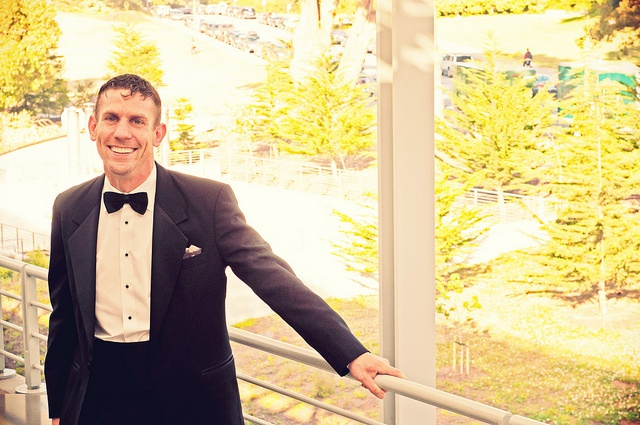Describe the objects in this image and their specific colors. I can see people in gold, black, tan, purple, and brown tones, car in gold, ivory, khaki, and tan tones, tie in gold, black, gray, tan, and darkgray tones, car in gold, khaki, beige, and darkgray tones, and car in gold, ivory, tan, and darkgray tones in this image. 